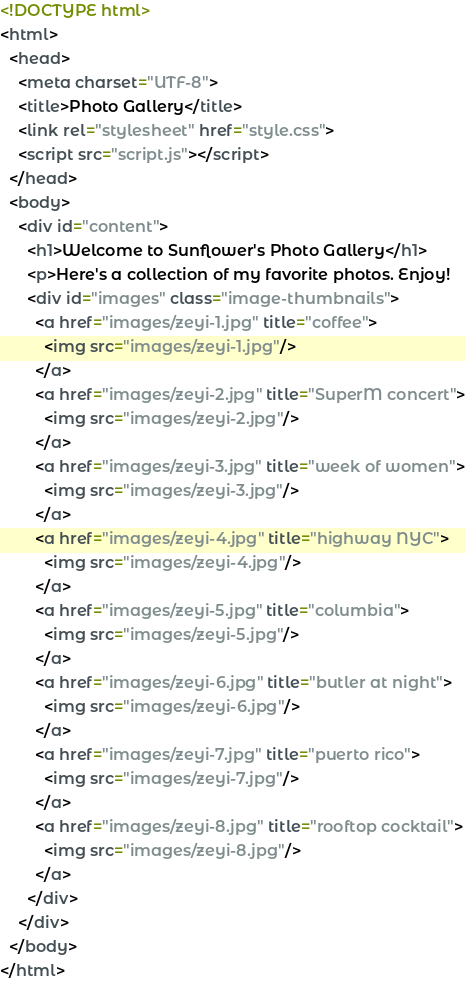Convert code to text. <code><loc_0><loc_0><loc_500><loc_500><_HTML_><!DOCTYPE html>
<html>
  <head>
    <meta charset="UTF-8">
    <title>Photo Gallery</title>
    <link rel="stylesheet" href="style.css">
    <script src="script.js"></script>
  </head>
  <body>
    <div id="content">
      <h1>Welcome to Sunflower's Photo Gallery</h1>
      <p>Here's a collection of my favorite photos. Enjoy!
      <div id="images" class="image-thumbnails">
        <a href="images/zeyi-1.jpg" title="coffee">
          <img src="images/zeyi-1.jpg"/>
        </a>
        <a href="images/zeyi-2.jpg" title="SuperM concert">
          <img src="images/zeyi-2.jpg"/>
        </a>
        <a href="images/zeyi-3.jpg" title="week of women">
          <img src="images/zeyi-3.jpg"/>
        </a>
        <a href="images/zeyi-4.jpg" title="highway NYC">
          <img src="images/zeyi-4.jpg"/>
        </a>
        <a href="images/zeyi-5.jpg" title="columbia">
          <img src="images/zeyi-5.jpg"/>
        </a>
        <a href="images/zeyi-6.jpg" title="butler at night">
          <img src="images/zeyi-6.jpg"/>
        </a>
        <a href="images/zeyi-7.jpg" title="puerto rico">
          <img src="images/zeyi-7.jpg"/>
        </a>
        <a href="images/zeyi-8.jpg" title="rooftop cocktail">
          <img src="images/zeyi-8.jpg"/>
        </a>
      </div>
    </div>
  </body>
</html></code> 